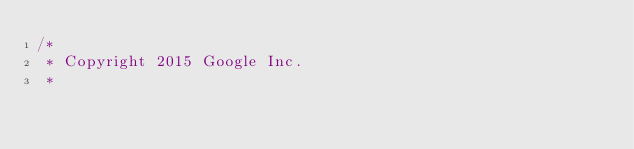<code> <loc_0><loc_0><loc_500><loc_500><_C_>/*
 * Copyright 2015 Google Inc.
 *</code> 